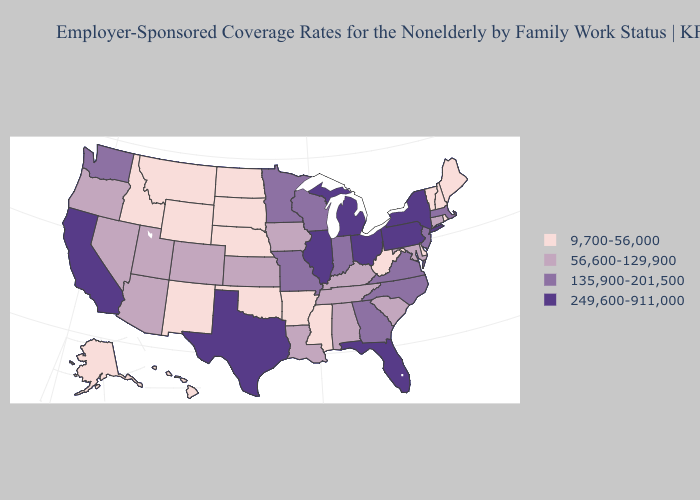Which states have the lowest value in the MidWest?
Concise answer only. Nebraska, North Dakota, South Dakota. Does Louisiana have the lowest value in the South?
Short answer required. No. What is the lowest value in the USA?
Keep it brief. 9,700-56,000. What is the value of New Hampshire?
Write a very short answer. 9,700-56,000. What is the value of Connecticut?
Be succinct. 56,600-129,900. Name the states that have a value in the range 249,600-911,000?
Quick response, please. California, Florida, Illinois, Michigan, New York, Ohio, Pennsylvania, Texas. What is the value of Nebraska?
Keep it brief. 9,700-56,000. What is the highest value in states that border Florida?
Write a very short answer. 135,900-201,500. Is the legend a continuous bar?
Concise answer only. No. Which states have the lowest value in the Northeast?
Answer briefly. Maine, New Hampshire, Rhode Island, Vermont. Does Kansas have the same value as New York?
Be succinct. No. What is the value of Arizona?
Keep it brief. 56,600-129,900. What is the value of Wyoming?
Concise answer only. 9,700-56,000. Name the states that have a value in the range 56,600-129,900?
Give a very brief answer. Alabama, Arizona, Colorado, Connecticut, Iowa, Kansas, Kentucky, Louisiana, Maryland, Nevada, Oregon, South Carolina, Tennessee, Utah. Does Utah have the lowest value in the West?
Quick response, please. No. 